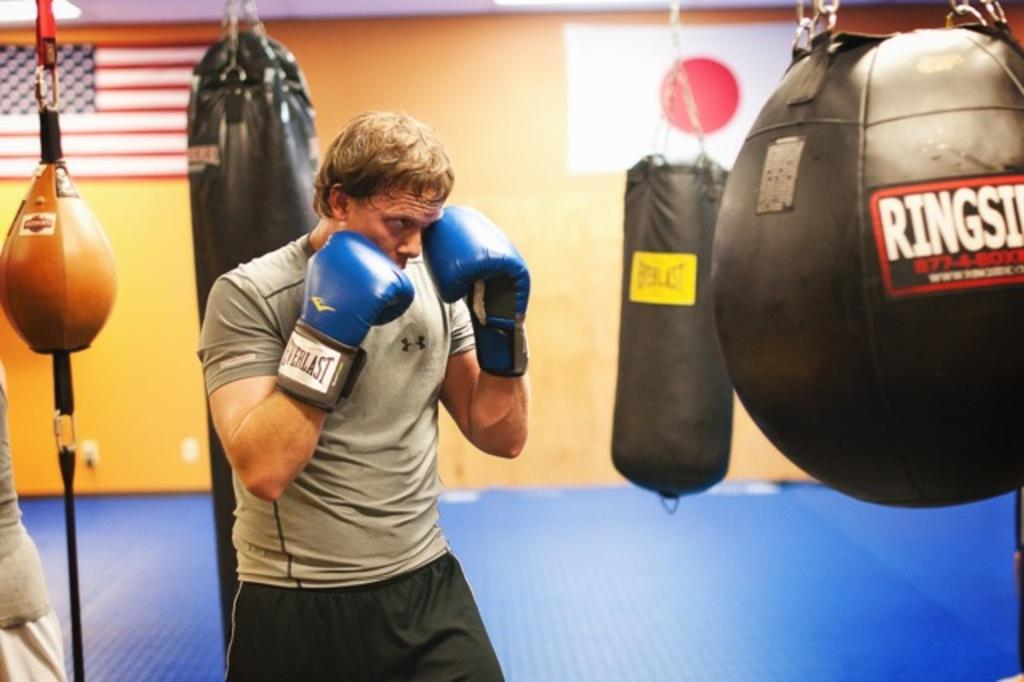<image>
Offer a succinct explanation of the picture presented. The boxer is wearing Everlast boxing gloves while bunching a bag. 